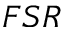<formula> <loc_0><loc_0><loc_500><loc_500>F S R</formula> 